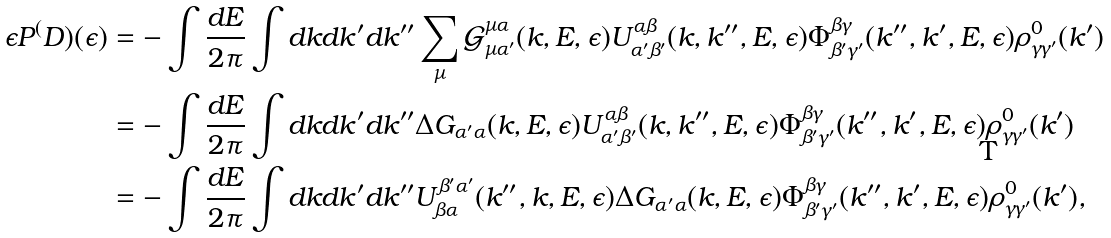Convert formula to latex. <formula><loc_0><loc_0><loc_500><loc_500>\epsilon P ^ { ( } D ) ( \epsilon ) & = - \int \frac { d E } { 2 \pi } \int d k d k ^ { \prime } d k ^ { \prime \prime } \sum _ { \mu } \mathcal { G } ^ { \mu \alpha } _ { \mu \alpha ^ { \prime } } ( k , E , \epsilon ) U ^ { \alpha \beta } _ { \alpha ^ { \prime } \beta ^ { \prime } } ( k , k ^ { \prime \prime } , E , \epsilon ) \Phi ^ { \beta \gamma } _ { \beta ^ { \prime } \gamma ^ { \prime } } ( k ^ { \prime \prime } , k ^ { \prime } , E , \epsilon ) \rho ^ { 0 } _ { \gamma \gamma ^ { \prime } } ( k ^ { \prime } ) \\ & = - \int \frac { d E } { 2 \pi } \int d k d k ^ { \prime } d k ^ { \prime \prime } \Delta G _ { \alpha ^ { \prime } \alpha } ( k , E , \epsilon ) U ^ { \alpha \beta } _ { \alpha ^ { \prime } \beta ^ { \prime } } ( k , k ^ { \prime \prime } , E , \epsilon ) \Phi ^ { \beta \gamma } _ { \beta ^ { \prime } \gamma ^ { \prime } } ( k ^ { \prime \prime } , k ^ { \prime } , E , \epsilon ) \rho ^ { 0 } _ { \gamma \gamma ^ { \prime } } ( k ^ { \prime } ) \\ & = - \int \frac { d E } { 2 \pi } \int d k d k ^ { \prime } d k ^ { \prime \prime } U ^ { \beta ^ { \prime } \alpha ^ { \prime } } _ { \beta \alpha } ( k ^ { \prime \prime } , k , E , \epsilon ) \Delta G _ { \alpha ^ { \prime } \alpha } ( k , E , \epsilon ) \Phi ^ { \beta \gamma } _ { \beta ^ { \prime } \gamma ^ { \prime } } ( k ^ { \prime \prime } , k ^ { \prime } , E , \epsilon ) \rho ^ { 0 } _ { \gamma \gamma ^ { \prime } } ( k ^ { \prime } ) ,</formula> 